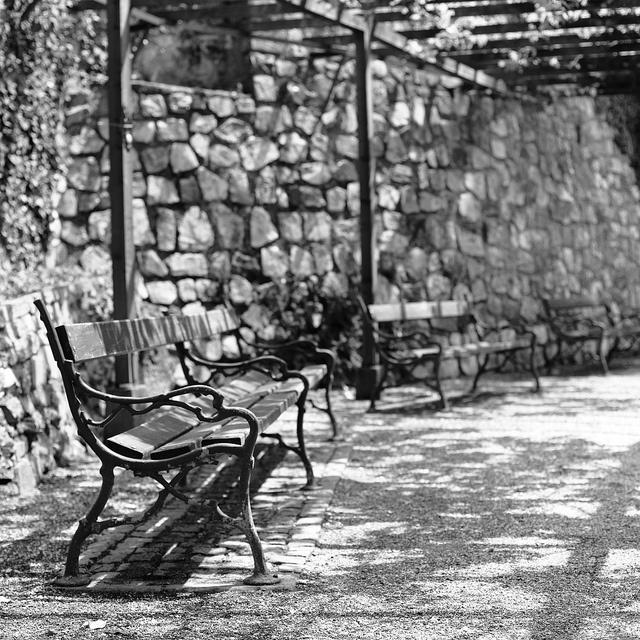Describe the objects in this image and their specific colors. I can see bench in lightgray, black, gray, and darkgray tones, bench in lightgray, gray, black, and darkgray tones, and bench in gray, black, and lightgray tones in this image. 